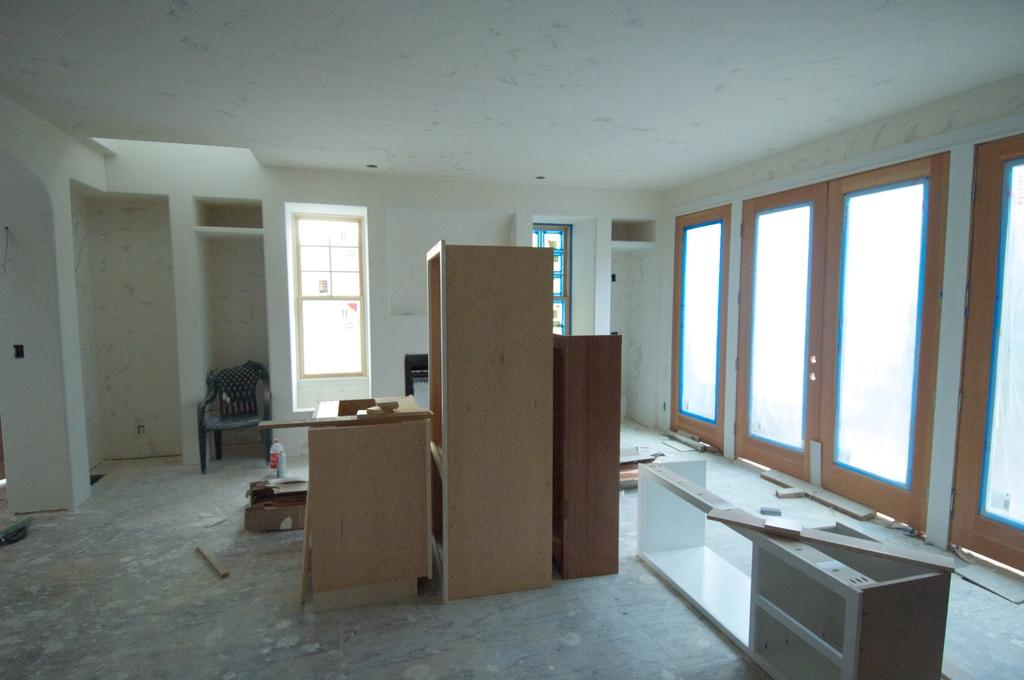What type of space is shown in the image? The image is an inside picture of a room. What type of furniture is present in the room? There are cupboards and a chair in the room. What architectural features can be seen in the room? There are doors and windows in the room. Are there any objects on the floor in the room? Yes, there are other objects on the floor in the room. What color is the tin on the sofa in the image? There is no sofa or tin present in the image. How many keys are hanging on the key rack in the image? There is no key rack or keys present in the image. 